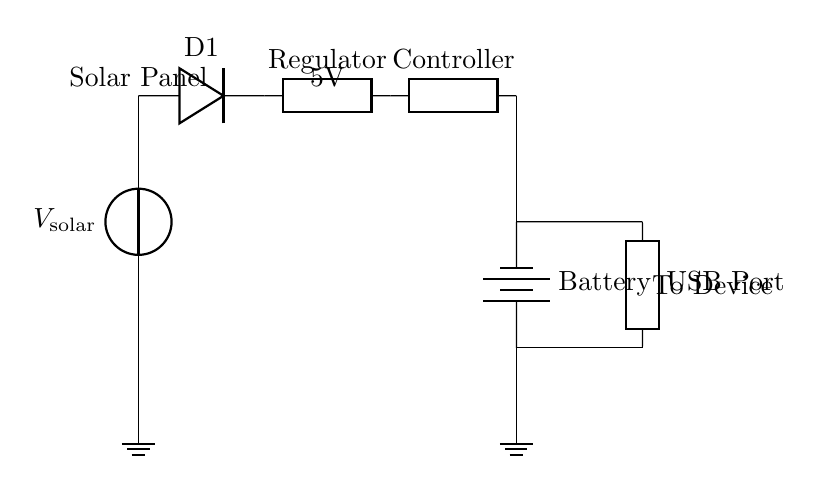What type of component is D1? D1 is a diode, indicated by the labeled component in the circuit diagram. It allows current to flow in one direction, which is essential for protecting the battery during charging.
Answer: Diode What is the function of the voltage regulator? The voltage regulator maintains a constant output voltage, ensuring that the battery receives the appropriate voltage for charging regardless of variations in solar panel output.
Answer: Regulator How many components are connected to the battery? Four components are connected to the battery: the charging controller, output to the USB port, ground, and the connection to the solar panel through the voltage regulator.
Answer: Four What is the output voltage provided to the device? The output voltage from the circuit is labeled as 5V, which is specified in the circuit diagram near the regulator. This voltage is suitable for charging many portable devices.
Answer: 5V What is the role of the charging controller? The charging controller regulates the charging process to the battery, ensuring it is efficiently charged without overcharging or damaging the battery.
Answer: Controller What connects the USB port to the battery? A short connection labeled as 'short' connects the USB port directly to the battery, allowing power to flow from the battery to the connected device.
Answer: Short What component is used to protect the battery from reverse polarity? The diode (D1) is used to prevent reverse polarity, as it only allows current to flow in one direction, thereby protecting the battery from potential damage.
Answer: Diode 